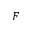Convert formula to latex. <formula><loc_0><loc_0><loc_500><loc_500>F</formula> 